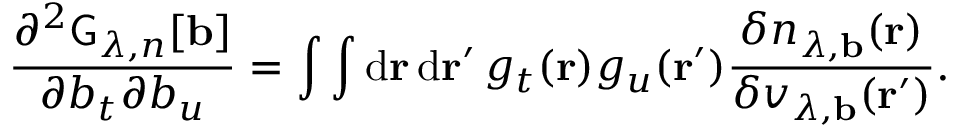<formula> <loc_0><loc_0><loc_500><loc_500>\frac { \partial ^ { 2 } G _ { \lambda , n } [ b ] } { \partial b _ { t } \partial b _ { u } } = \int \int d r \, d r ^ { \prime } \, g _ { t } ( r ) g _ { u } ( r ^ { \prime } ) \frac { \delta n _ { \lambda , b } ( r ) } { \delta v _ { \lambda , b } ( r ^ { \prime } ) } .</formula> 